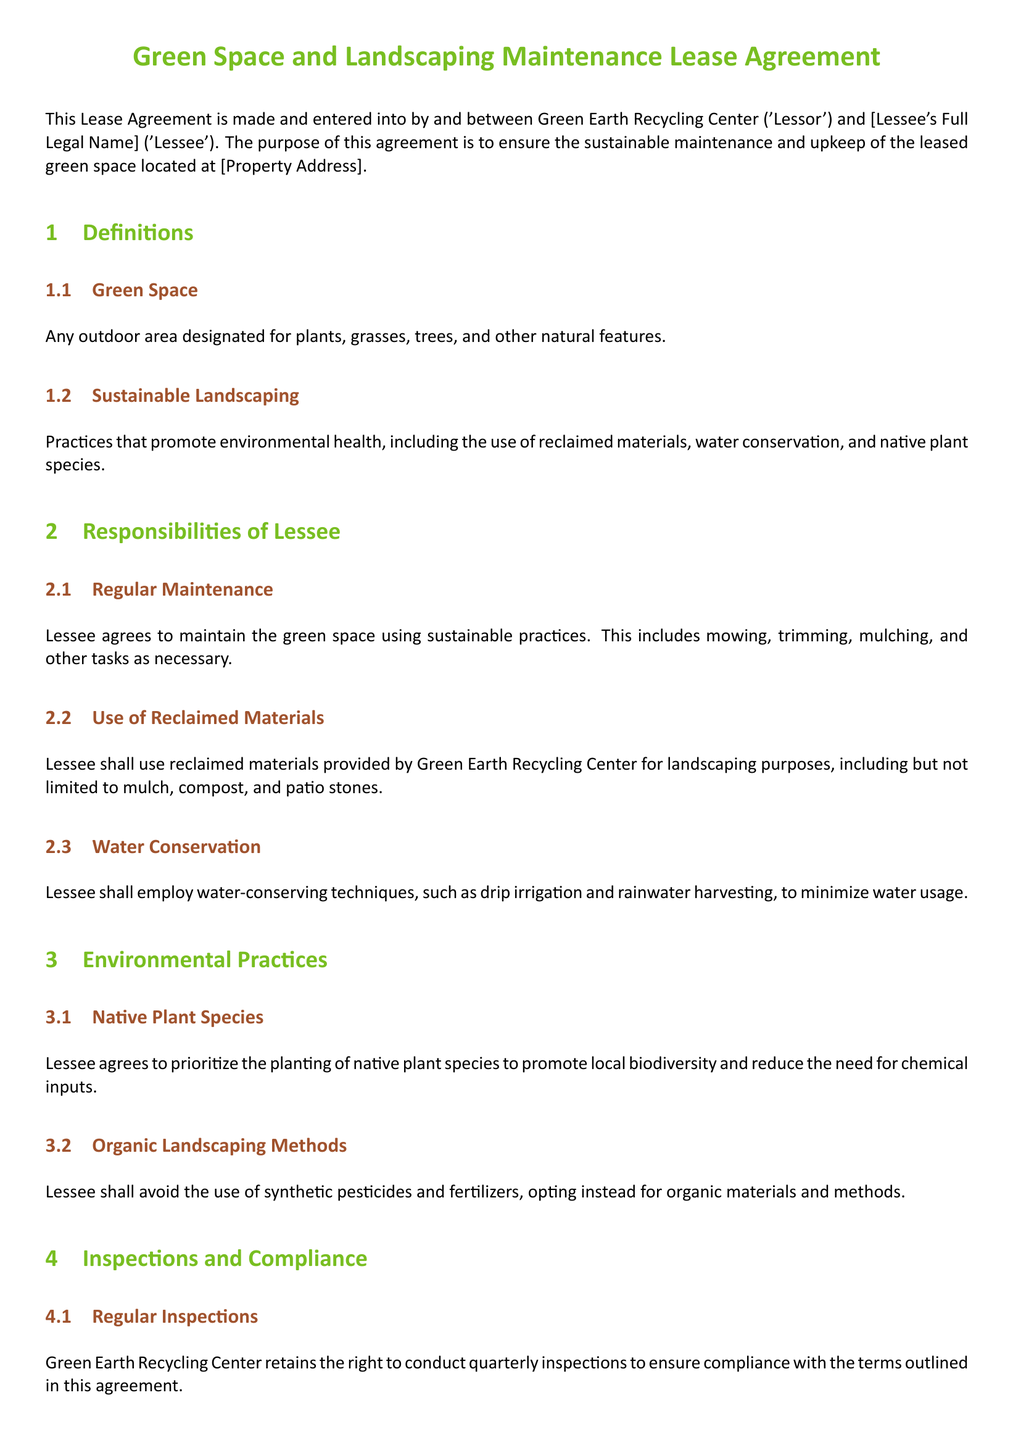What is the lessor's name? The lessor's name is the entity that provides the lease, which in this case is Green Earth Recycling Center.
Answer: Green Earth Recycling Center What is the main purpose of the lease agreement? The main purpose of the lease agreement is outlined in the introduction of the document, which is to ensure sustainable maintenance and upkeep of the leased green space.
Answer: Sustainable maintenance and upkeep What practice must the lessee prioritize when maintaining the green space? This information is specifically mentioned in the environmental practices section, stating that the lessee should prioritize a particular type of plant for the green space.
Answer: Native plant species How often are inspections conducted? The frequency of inspections by the lessor is stated in the inspections section of the document.
Answer: Quarterly What materials must the lessee use for landscaping purposes? The section on the responsibilities of the lessee specifies what type of materials must be used for sustainable landscaping.
Answer: Reclaimed materials What happens if there is non-compliance with the agreement? The consequence of failing to adhere to the terms is described in the non-compliance section, indicating what will happen if the lessee does not follow the sustainable landscaping practices.
Answer: Written notice Which irrigation technique must be employed by the lessee? The document specifies a type of technique to conserve water, which falls under the responsibilities of the lessee section.
Answer: Drip irrigation What should the lessee avoid using in their landscaping methods? The environmental practices section specifies types of substances that should not be used, guiding the lessee on what to avoid.
Answer: Synthetic pesticides and fertilizers 